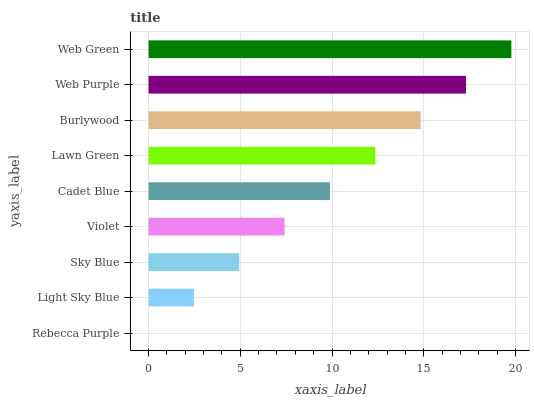Is Rebecca Purple the minimum?
Answer yes or no. Yes. Is Web Green the maximum?
Answer yes or no. Yes. Is Light Sky Blue the minimum?
Answer yes or no. No. Is Light Sky Blue the maximum?
Answer yes or no. No. Is Light Sky Blue greater than Rebecca Purple?
Answer yes or no. Yes. Is Rebecca Purple less than Light Sky Blue?
Answer yes or no. Yes. Is Rebecca Purple greater than Light Sky Blue?
Answer yes or no. No. Is Light Sky Blue less than Rebecca Purple?
Answer yes or no. No. Is Cadet Blue the high median?
Answer yes or no. Yes. Is Cadet Blue the low median?
Answer yes or no. Yes. Is Sky Blue the high median?
Answer yes or no. No. Is Violet the low median?
Answer yes or no. No. 